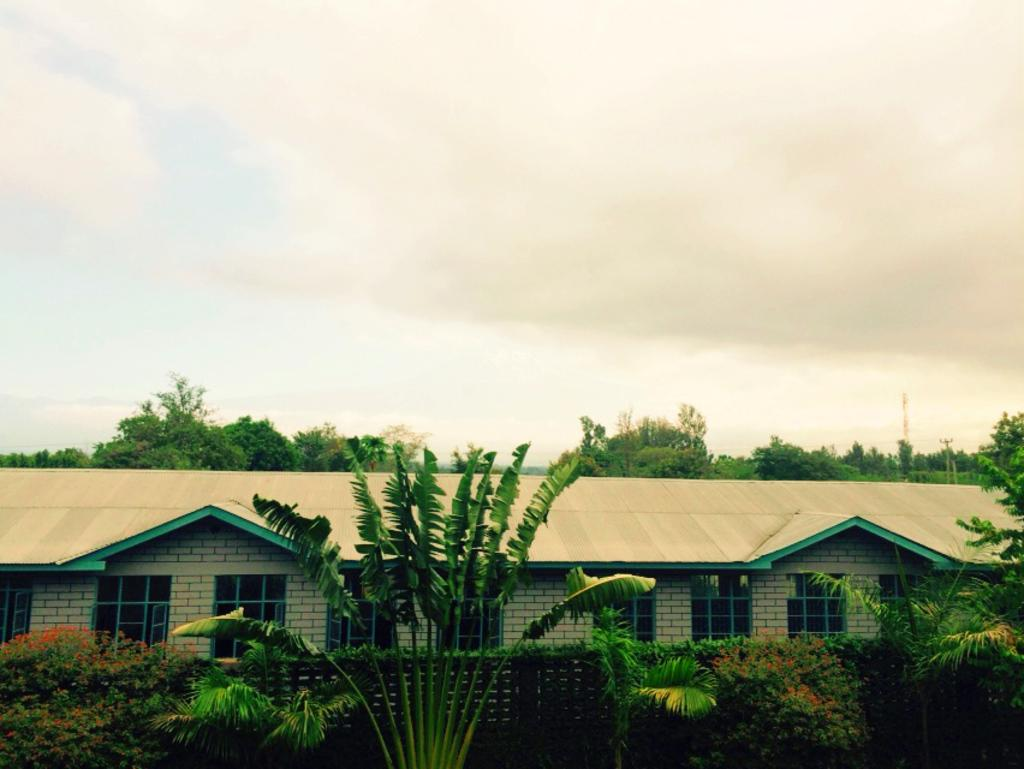What type of vegetation is at the bottom of the image? There are trees at the bottom of the image. What structure is located in the middle of the image? There is a house in the middle of the image. What is visible at the top of the image? The sky is visible at the top of the image. What grade is the house in the image? The provided facts do not mention any grade or level for the house, so it cannot be determined from the image. Can you see the chin of the trees in the image? The image does not depict a chin or any facial features, as it features trees, a house, and the sky. 